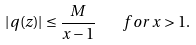Convert formula to latex. <formula><loc_0><loc_0><loc_500><loc_500>| q ( z ) | \leq \frac { M } { x - 1 } \quad f o r \, x > 1 .</formula> 